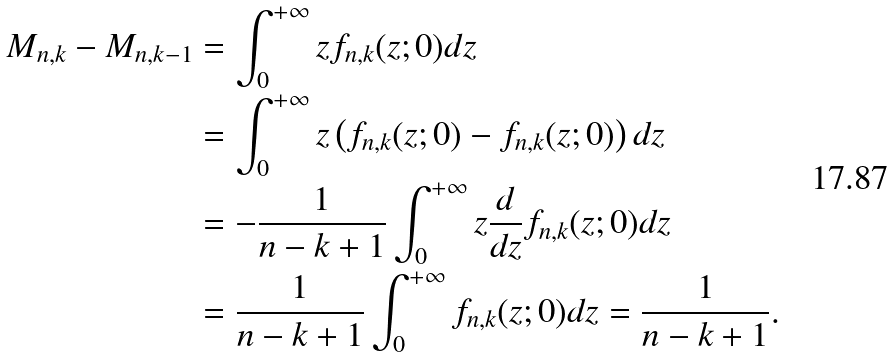<formula> <loc_0><loc_0><loc_500><loc_500>M _ { n , k } - M _ { n , k - 1 } & = \int _ { 0 } ^ { + \infty } z f _ { n , k } ( z ; 0 ) d z \\ & = \int _ { 0 } ^ { + \infty } z \left ( f _ { n , k } ( z ; 0 ) - f _ { n , k } ( z ; 0 ) \right ) d z \\ & = - \frac { 1 } { n - k + 1 } \int _ { 0 } ^ { + \infty } z \frac { d } { d z } f _ { n , k } ( z ; 0 ) d z \\ & = \frac { 1 } { n - k + 1 } \int _ { 0 } ^ { + \infty } f _ { n , k } ( z ; 0 ) d z = \frac { 1 } { n - k + 1 } .</formula> 